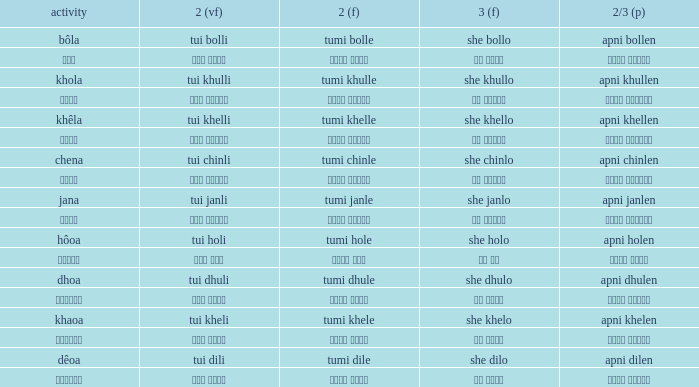What is the 2nd verb for chena? Tumi chinle. 